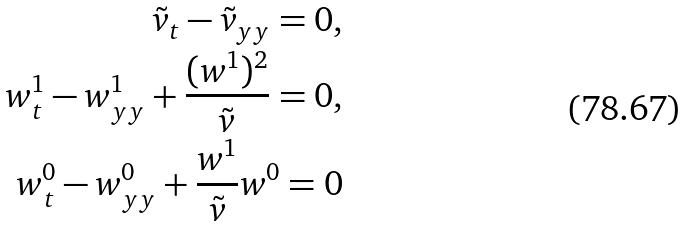<formula> <loc_0><loc_0><loc_500><loc_500>\tilde { v } _ { t } - \tilde { v } _ { y y } = 0 , \\ w ^ { 1 } _ { t } - w ^ { 1 } _ { y y } + \frac { ( w ^ { 1 } ) ^ { 2 } } { \tilde { v } } = 0 , \\ w ^ { 0 } _ { t } - w ^ { 0 } _ { y y } + \frac { w ^ { 1 } } { \tilde { v } } w ^ { 0 } = 0</formula> 